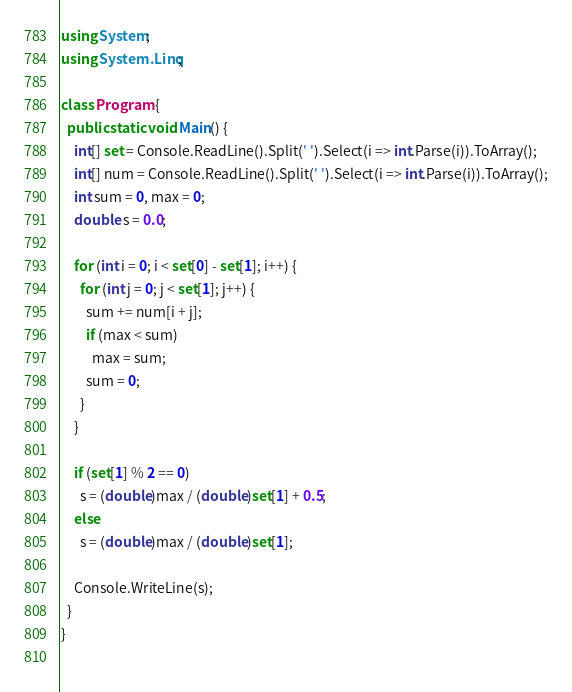Convert code to text. <code><loc_0><loc_0><loc_500><loc_500><_C#_>using System;
using System.Linq;

class Program {
  public static void Main() {
    int[] set = Console.ReadLine().Split(' ').Select(i => int.Parse(i)).ToArray();
    int[] num = Console.ReadLine().Split(' ').Select(i => int.Parse(i)).ToArray();
    int sum = 0, max = 0;
    double s = 0.0;
    
    for (int i = 0; i < set[0] - set[1]; i++) {
      for (int j = 0; j < set[1]; j++) {
        sum += num[i + j];
        if (max < sum)
          max = sum;
        sum = 0;
      }
    }
    
    if (set[1] % 2 == 0)
      s = (double)max / (double)set[1] + 0.5;
    else
      s = (double)max / (double)set[1];
    
    Console.WriteLine(s);
  }
}
    
</code> 